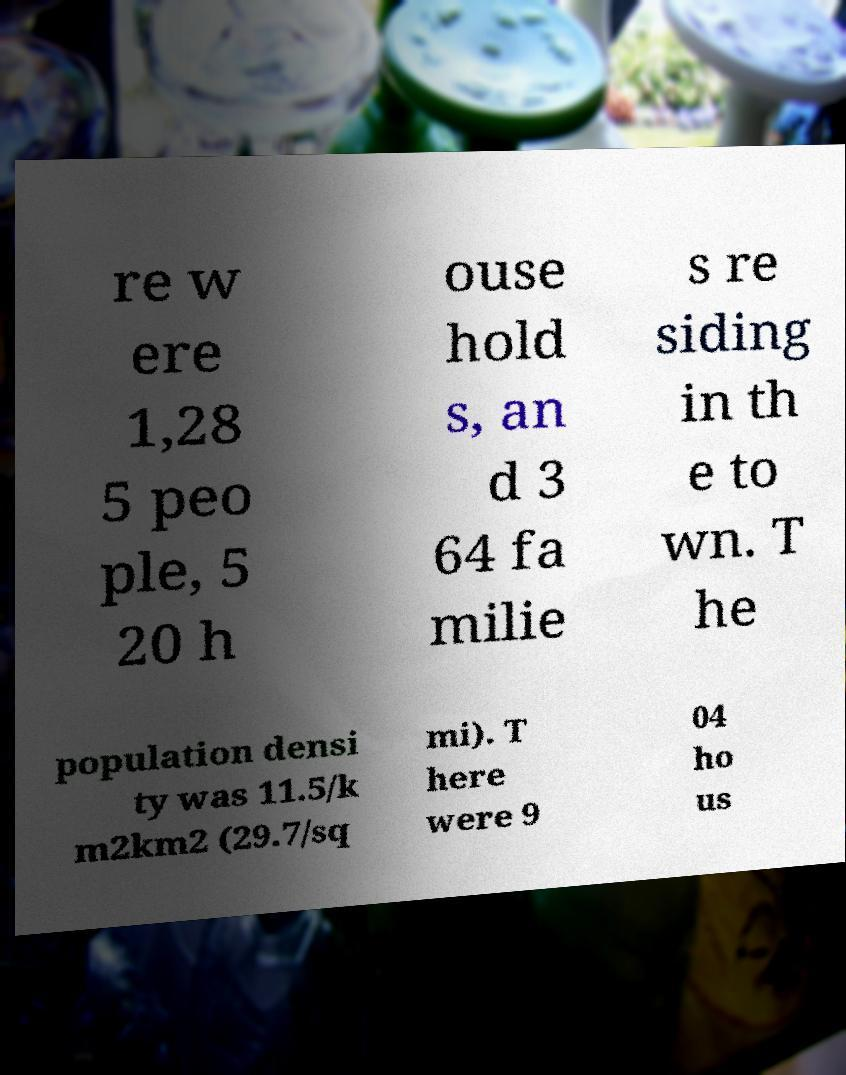What messages or text are displayed in this image? I need them in a readable, typed format. re w ere 1,28 5 peo ple, 5 20 h ouse hold s, an d 3 64 fa milie s re siding in th e to wn. T he population densi ty was 11.5/k m2km2 (29.7/sq mi). T here were 9 04 ho us 